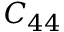Convert formula to latex. <formula><loc_0><loc_0><loc_500><loc_500>C _ { 4 4 }</formula> 